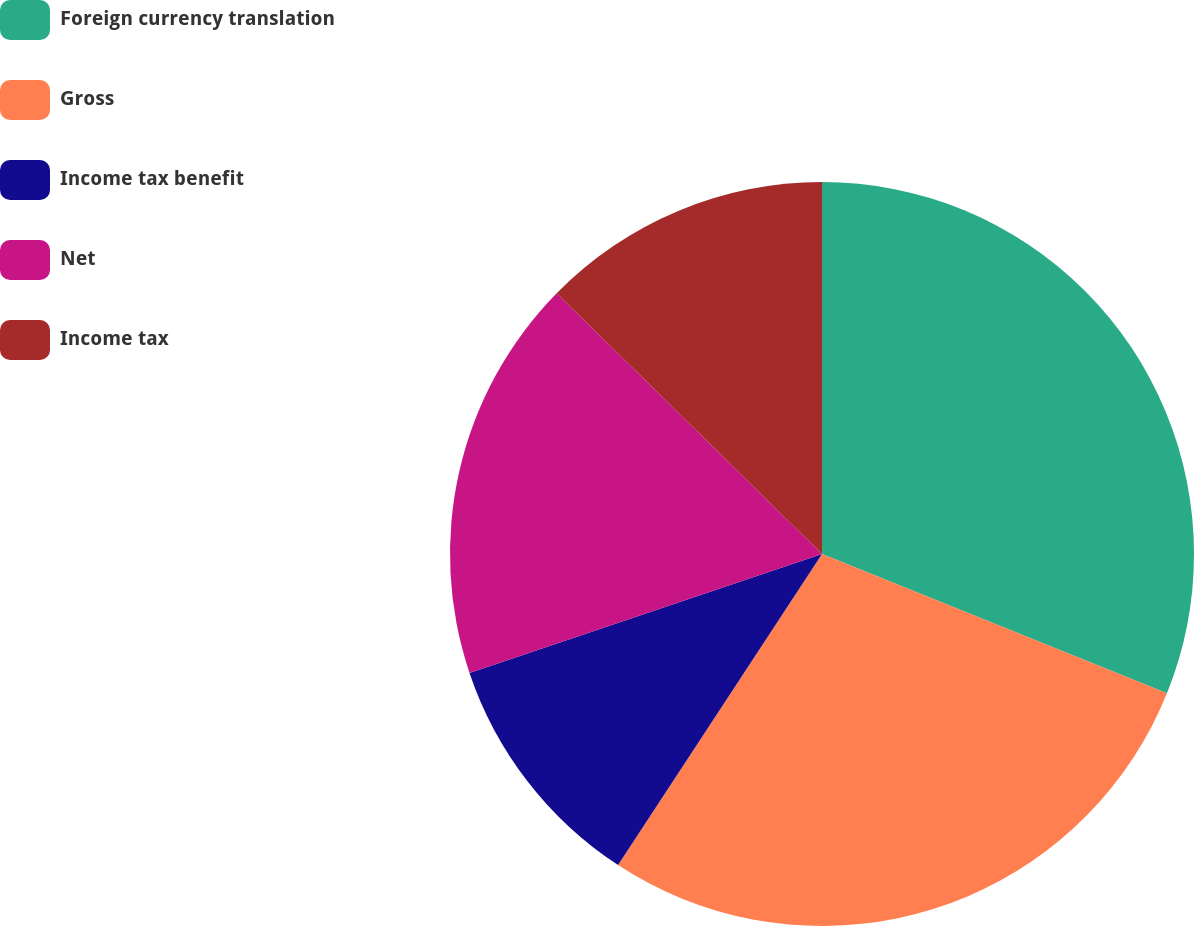Convert chart. <chart><loc_0><loc_0><loc_500><loc_500><pie_chart><fcel>Foreign currency translation<fcel>Gross<fcel>Income tax benefit<fcel>Net<fcel>Income tax<nl><fcel>31.11%<fcel>28.13%<fcel>10.59%<fcel>17.54%<fcel>12.64%<nl></chart> 